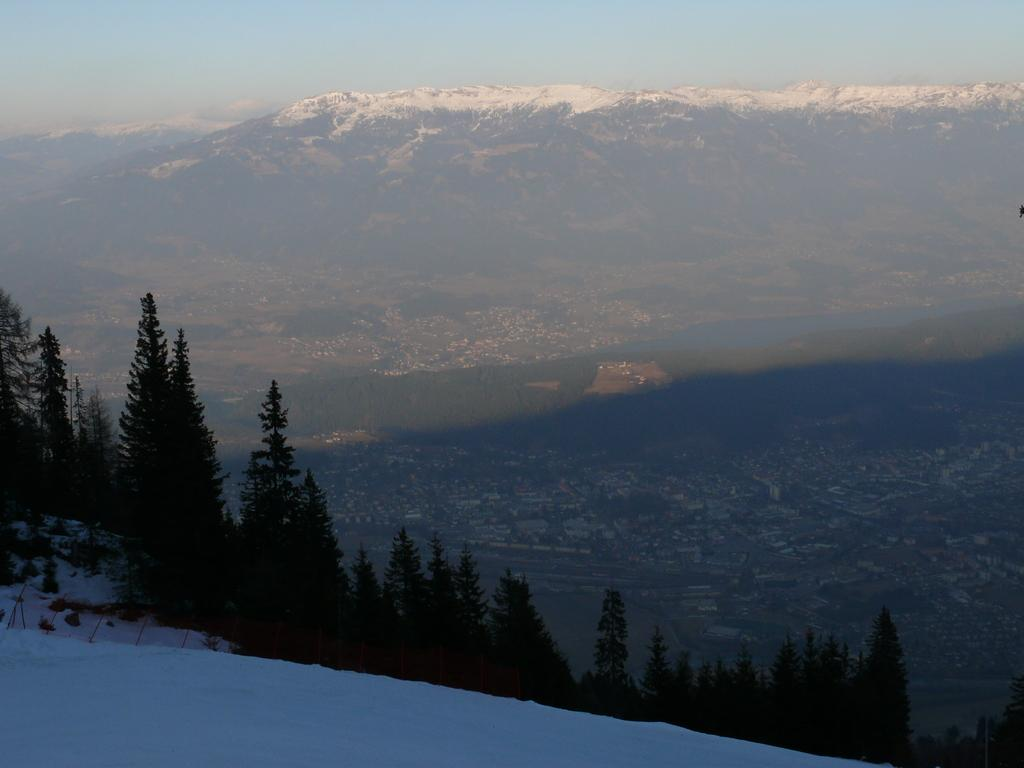What type of vegetation can be seen in the image? There are trees in the image. What is the weather like in the image? There is snow in the image, indicating a cold or wintery environment. What can be seen in the background of the image? There are mountains, water, and the sky visible in the background of the image. Can you see any honey dripping from the trees in the image? There is no honey present in the image; it features trees with snow. 